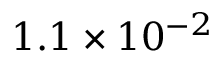Convert formula to latex. <formula><loc_0><loc_0><loc_500><loc_500>1 . 1 \times 1 0 ^ { - 2 }</formula> 